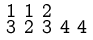Convert formula to latex. <formula><loc_0><loc_0><loc_500><loc_500>\begin{smallmatrix} 1 & 1 & 2 \\ 3 & 2 & 3 & 4 & 4 \end{smallmatrix}</formula> 